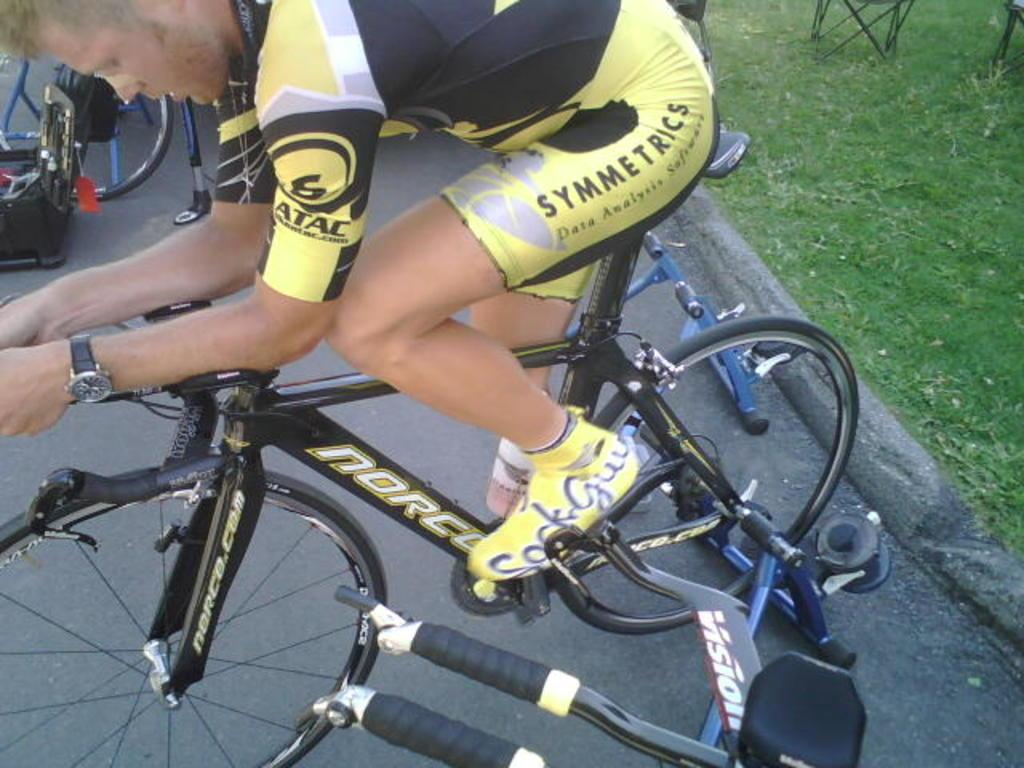What is the man in the image doing? The man is seated on a bicycle in the image. How many bicycles can be seen in the image? There are at least two bicycles visible in the image. What type of surface is the man seated on the bicycle on? Grass is present on the ground in the image. What other piece of furniture is present in the image? There is a chair in the image. How many trees are visible in the image? There are no trees visible in the image. Who is the friend of the man seated on the bicycle in the image? There is no friend of the man seated on the bicycle present in the image. 